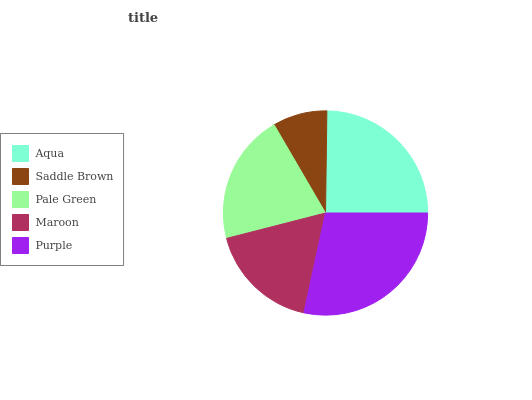Is Saddle Brown the minimum?
Answer yes or no. Yes. Is Purple the maximum?
Answer yes or no. Yes. Is Pale Green the minimum?
Answer yes or no. No. Is Pale Green the maximum?
Answer yes or no. No. Is Pale Green greater than Saddle Brown?
Answer yes or no. Yes. Is Saddle Brown less than Pale Green?
Answer yes or no. Yes. Is Saddle Brown greater than Pale Green?
Answer yes or no. No. Is Pale Green less than Saddle Brown?
Answer yes or no. No. Is Pale Green the high median?
Answer yes or no. Yes. Is Pale Green the low median?
Answer yes or no. Yes. Is Aqua the high median?
Answer yes or no. No. Is Purple the low median?
Answer yes or no. No. 